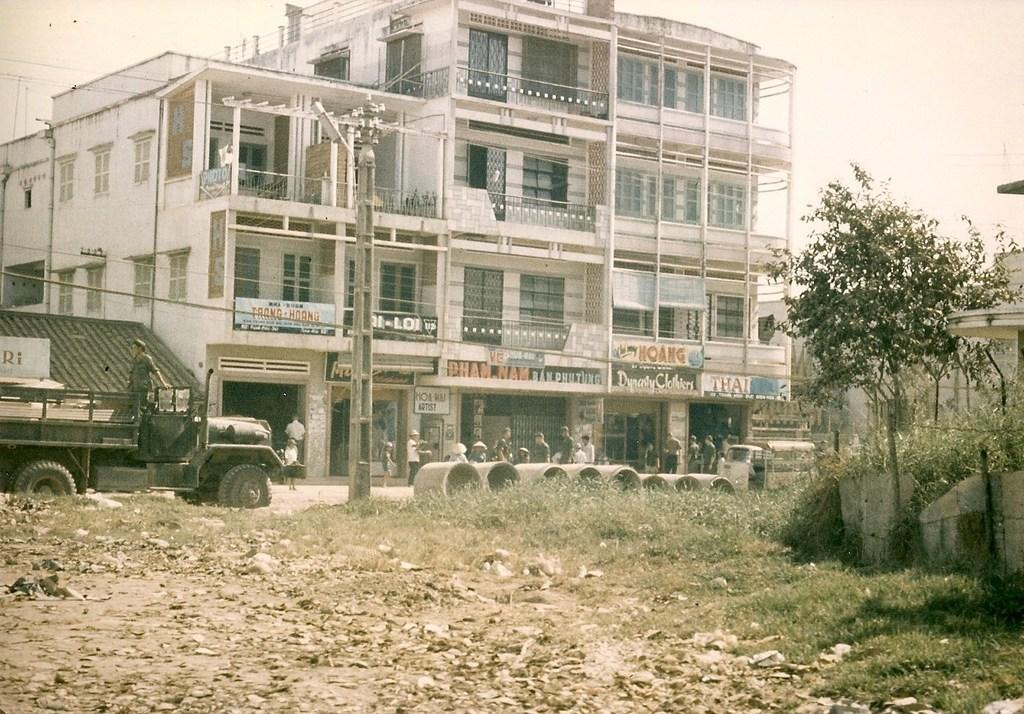What is the main subject of the image? The main subject of the image is a truck. What is the truck doing in the image? The truck is moving on the road in the image. What type of vegetation is present on the floor? There is grass on the floor in the image. What else can be seen on the floor? There are dry leaves on the floor in the image. What can be seen in the background of the image? There is a building in the backdrop of the image. What type of scarf is the detail expert wearing in the image? There is no detail expert or scarf present in the image; it features a truck moving on the road. 